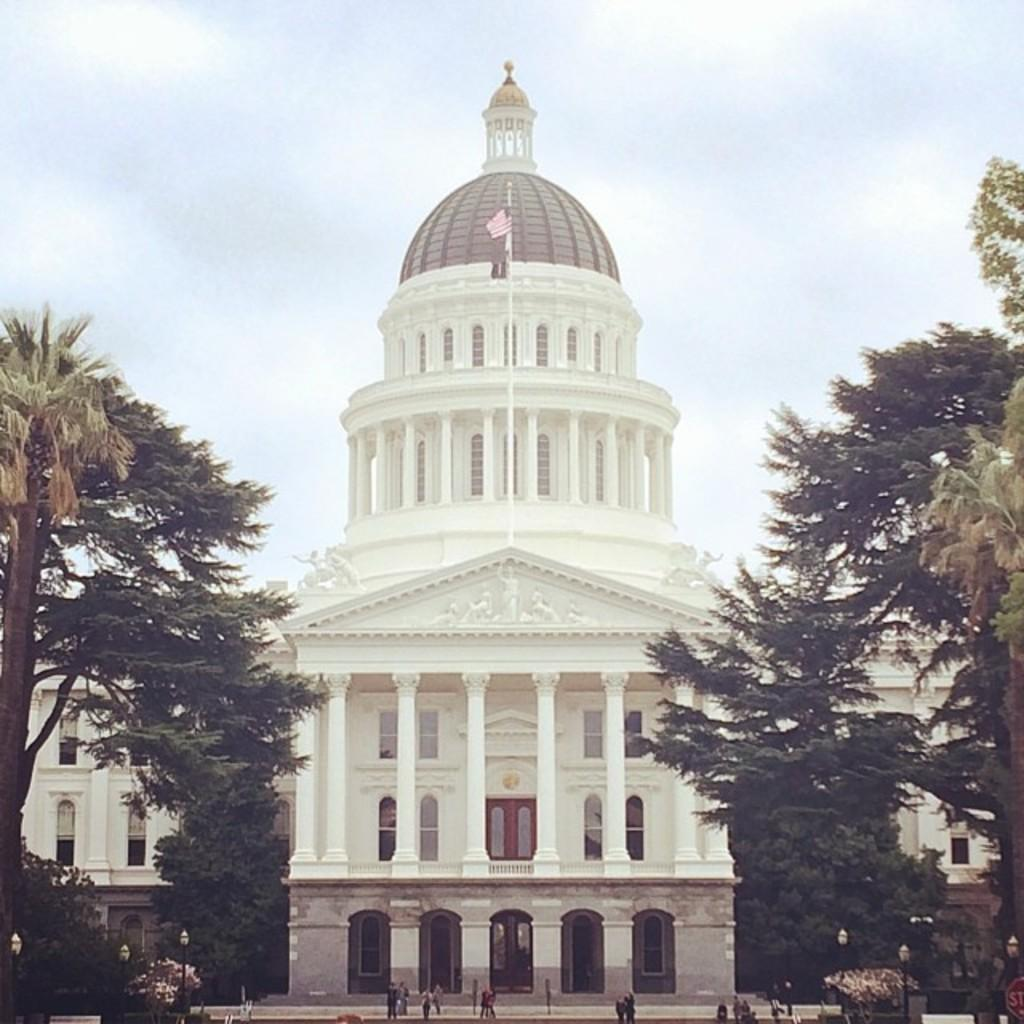What are the people in the image doing? The people in the image are walking. What structures can be seen in the image? There are light poles in the image. What type of vegetation is present in the image? There are trees in the image. What type of building can be seen in the image? There is a white building in the image. What is visible in the background of the image? The sky is visible in the background of the image. Can you see any fairies flying around the trees in the image? There are no fairies present in the image; it only features people walking, light poles, trees, a white building, and the sky. 